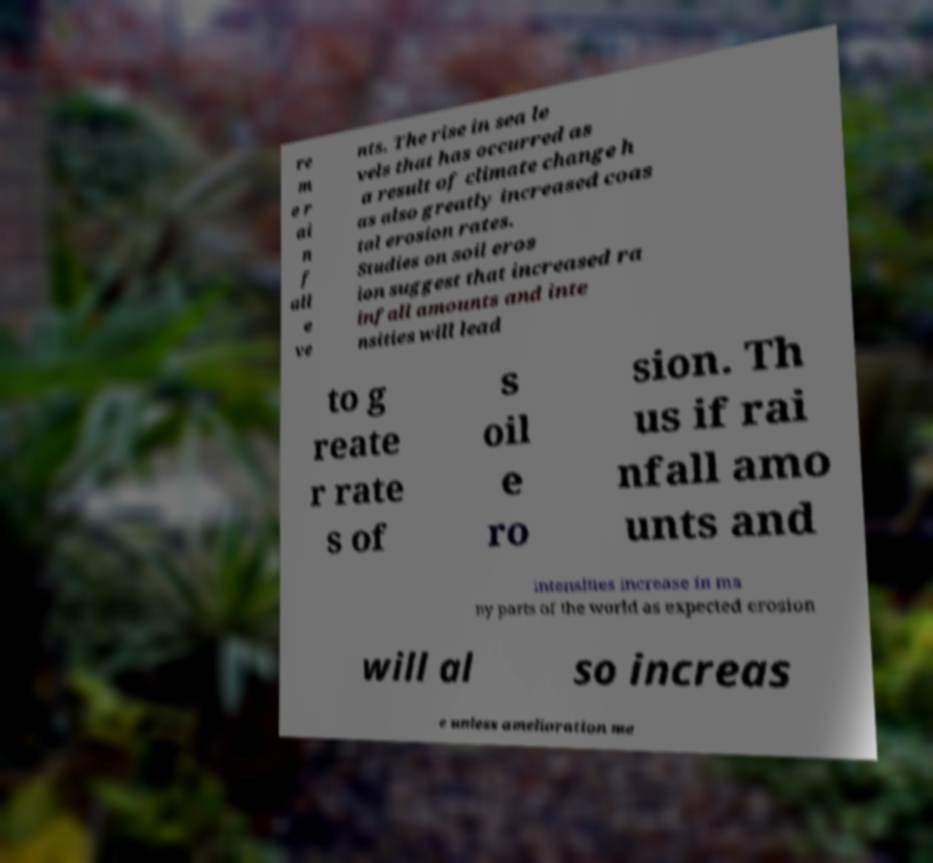Could you extract and type out the text from this image? re m e r ai n f all e ve nts. The rise in sea le vels that has occurred as a result of climate change h as also greatly increased coas tal erosion rates. Studies on soil eros ion suggest that increased ra infall amounts and inte nsities will lead to g reate r rate s of s oil e ro sion. Th us if rai nfall amo unts and intensities increase in ma ny parts of the world as expected erosion will al so increas e unless amelioration me 